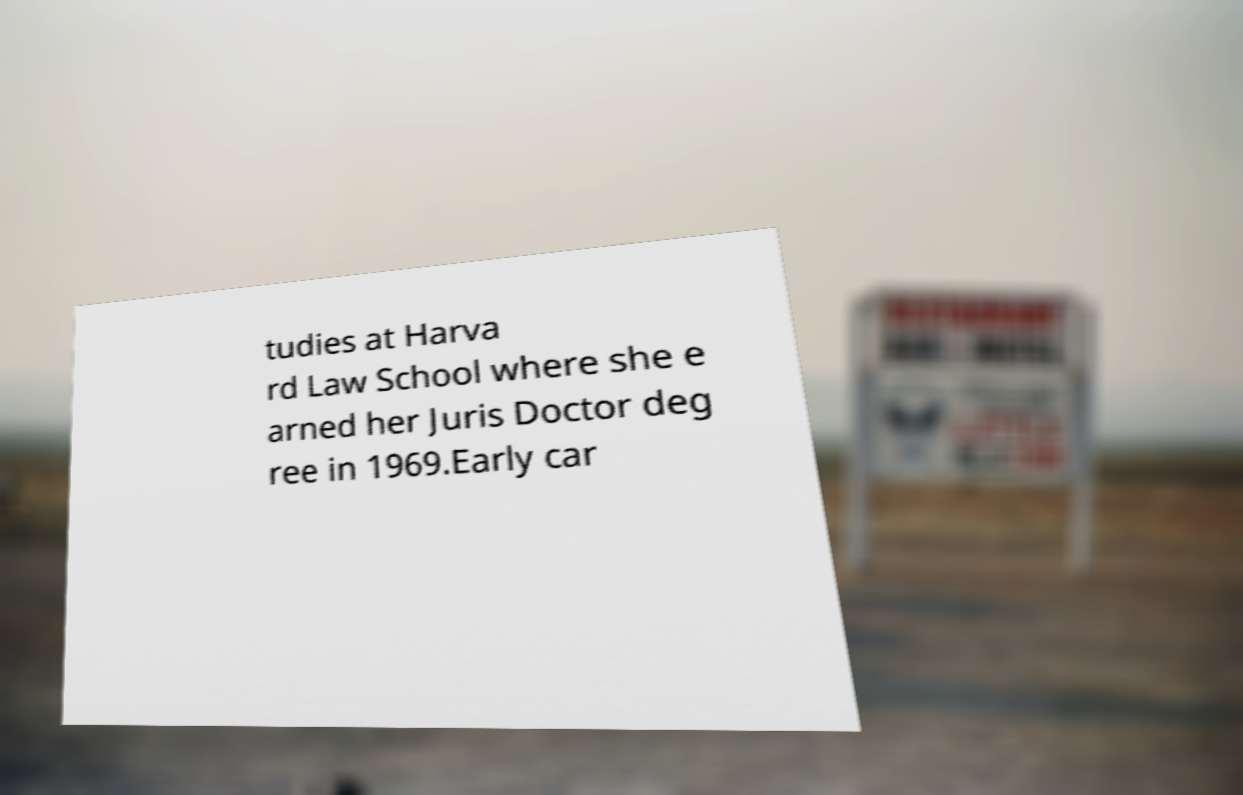What messages or text are displayed in this image? I need them in a readable, typed format. tudies at Harva rd Law School where she e arned her Juris Doctor deg ree in 1969.Early car 